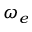<formula> <loc_0><loc_0><loc_500><loc_500>\omega _ { e }</formula> 